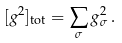Convert formula to latex. <formula><loc_0><loc_0><loc_500><loc_500>[ g ^ { 2 } ] _ { \text {tot} } = \sum _ { \sigma } g _ { \sigma } ^ { 2 } \, .</formula> 